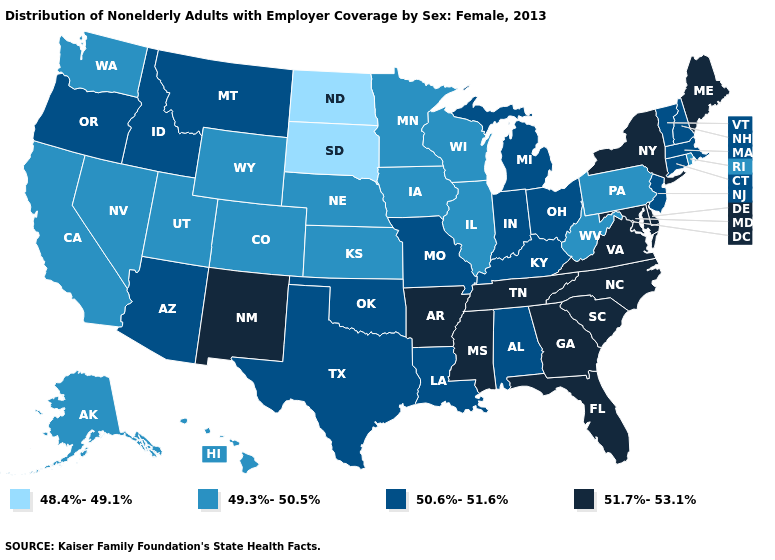What is the value of Kansas?
Write a very short answer. 49.3%-50.5%. Name the states that have a value in the range 50.6%-51.6%?
Answer briefly. Alabama, Arizona, Connecticut, Idaho, Indiana, Kentucky, Louisiana, Massachusetts, Michigan, Missouri, Montana, New Hampshire, New Jersey, Ohio, Oklahoma, Oregon, Texas, Vermont. Among the states that border Virginia , does Kentucky have the highest value?
Write a very short answer. No. What is the value of Illinois?
Answer briefly. 49.3%-50.5%. Among the states that border Indiana , which have the lowest value?
Quick response, please. Illinois. Among the states that border Maryland , which have the lowest value?
Keep it brief. Pennsylvania, West Virginia. Does the first symbol in the legend represent the smallest category?
Answer briefly. Yes. Name the states that have a value in the range 48.4%-49.1%?
Short answer required. North Dakota, South Dakota. Name the states that have a value in the range 50.6%-51.6%?
Write a very short answer. Alabama, Arizona, Connecticut, Idaho, Indiana, Kentucky, Louisiana, Massachusetts, Michigan, Missouri, Montana, New Hampshire, New Jersey, Ohio, Oklahoma, Oregon, Texas, Vermont. What is the value of South Carolina?
Give a very brief answer. 51.7%-53.1%. What is the value of Vermont?
Be succinct. 50.6%-51.6%. Does North Dakota have the lowest value in the USA?
Short answer required. Yes. What is the lowest value in states that border Pennsylvania?
Quick response, please. 49.3%-50.5%. Which states have the lowest value in the Northeast?
Keep it brief. Pennsylvania, Rhode Island. Which states have the highest value in the USA?
Give a very brief answer. Arkansas, Delaware, Florida, Georgia, Maine, Maryland, Mississippi, New Mexico, New York, North Carolina, South Carolina, Tennessee, Virginia. 